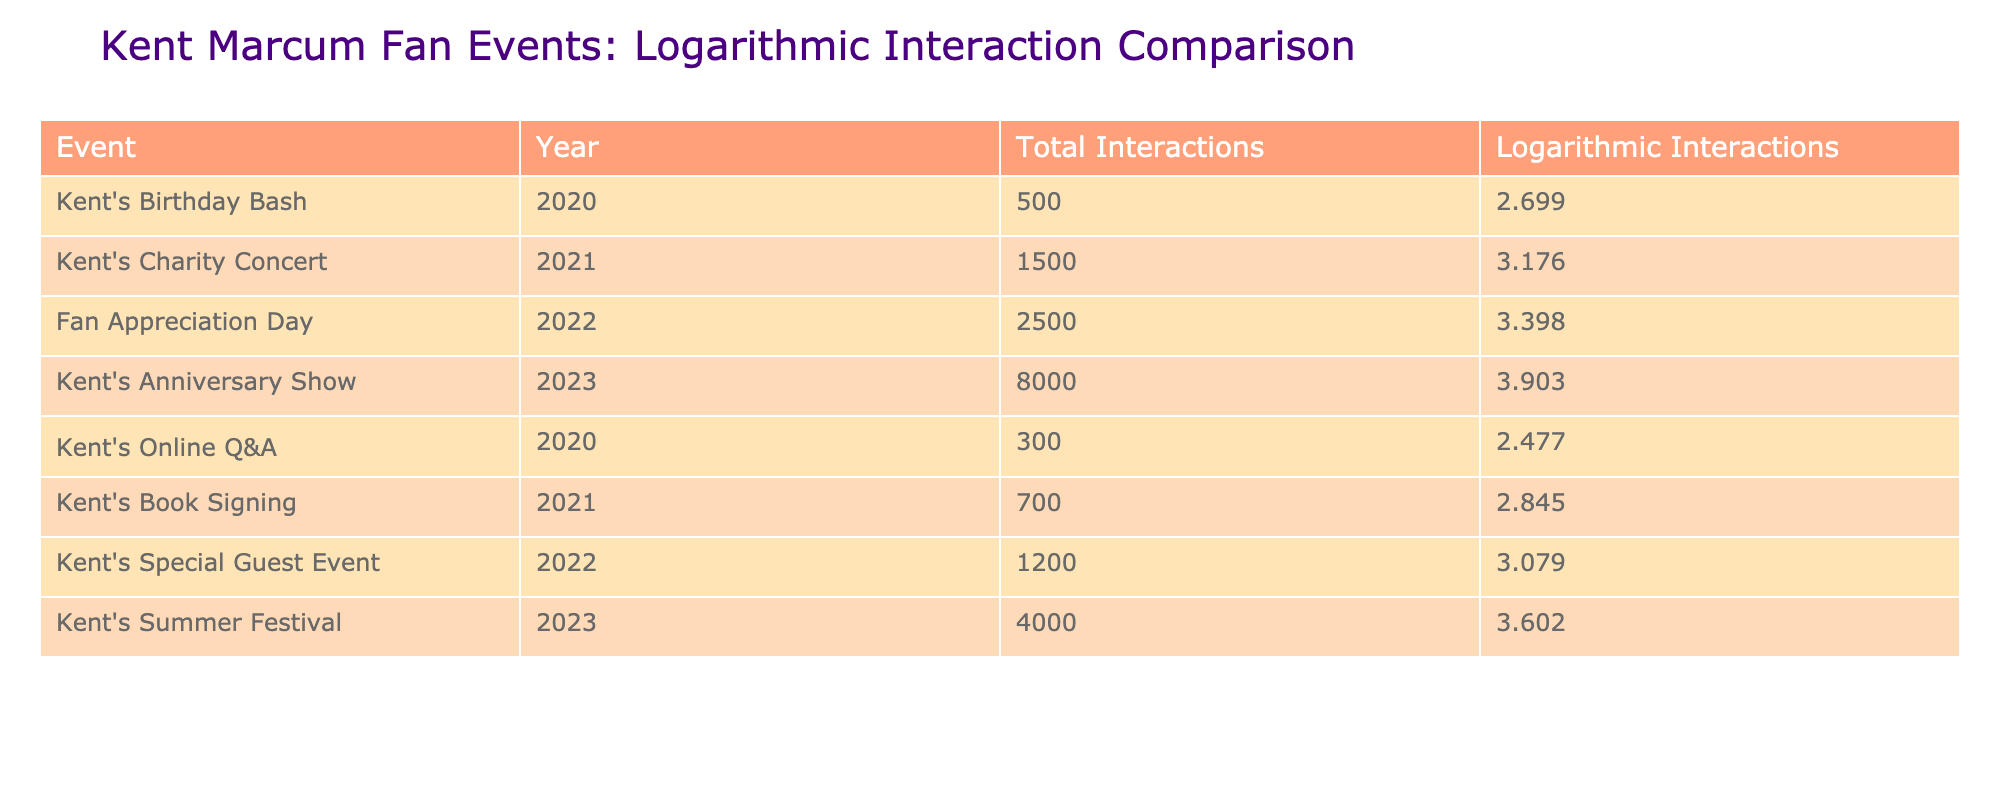What was the total number of interactions for Kent's Charity Concert in 2021? The table lists the total interactions for Kent's Charity Concert in 2021, which shows a value of 1500 under the "Total Interactions" column.
Answer: 1500 How many events had more than 1000 total interactions? By looking at the "Total Interactions" column, the events with more than 1000 interactions are: Kent's Charity Concert (1500), Fan Appreciation Day (2500), Kent's Anniversary Show (8000), Kent's Special Guest Event (1200), and Kent's Summer Festival (4000). This totals to 5 events.
Answer: 5 What is the difference in logarithmic interactions between Kent's Anniversary Show and Kent's Charity Concert? The logarithmic interactions for Kent's Anniversary Show is 3.903 and for Kent's Charity Concert is 3.176. The difference is calculated as 3.903 - 3.176 = 0.727.
Answer: 0.727 Is the total number of interactions for Kent's Summer Festival greater than or equal to the sum of interactions for Kent's Birthday Bash and Kent's Online Q&A? The total interactions for Kent's Summer Festival are 4000. The sum of Kent's Birthday Bash (500) and Kent's Online Q&A (300) is 500 + 300 = 800. Since 4000 is greater than 800, the answer is yes.
Answer: Yes What was the average number of total interactions across all events listed from 2020 to 2023? First, sum the total interactions for all events: 500 + 1500 + 2500 + 8000 + 300 + 700 + 1200 + 4000 = 15800. There are 8 events, so the average is calculated by dividing the total by the number of events: 15800 / 8 = 1975.
Answer: 1975 How many events took place in 2022? The table lists the events for 2022 which are Fan Appreciation Day and Kent's Special Guest Event, totaling 2 events.
Answer: 2 Which event had the highest total interactions, and what was that number? By examining the "Total Interactions" column, Kent's Anniversary Show in 2023 has the highest interactions at 8000.
Answer: 8000 What is the logarithmic value of interactions for Kent's Book Signing compared to online Q&A? Kent's Book Signing has a logarithmic value of 2.845 while Kent's Online Q&A has a logarithmic value of 2.477. The difference indicates that Kent's Book Signing had a higher logarithmic interaction value of 0.368.
Answer: 0.368 